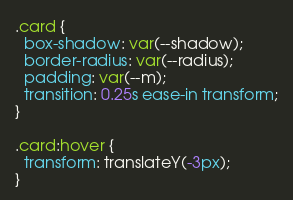Convert code to text. <code><loc_0><loc_0><loc_500><loc_500><_CSS_>.card {
  box-shadow: var(--shadow);
  border-radius: var(--radius);
  padding: var(--m);
  transition: 0.25s ease-in transform;
}

.card:hover {
  transform: translateY(-3px);
}
</code> 